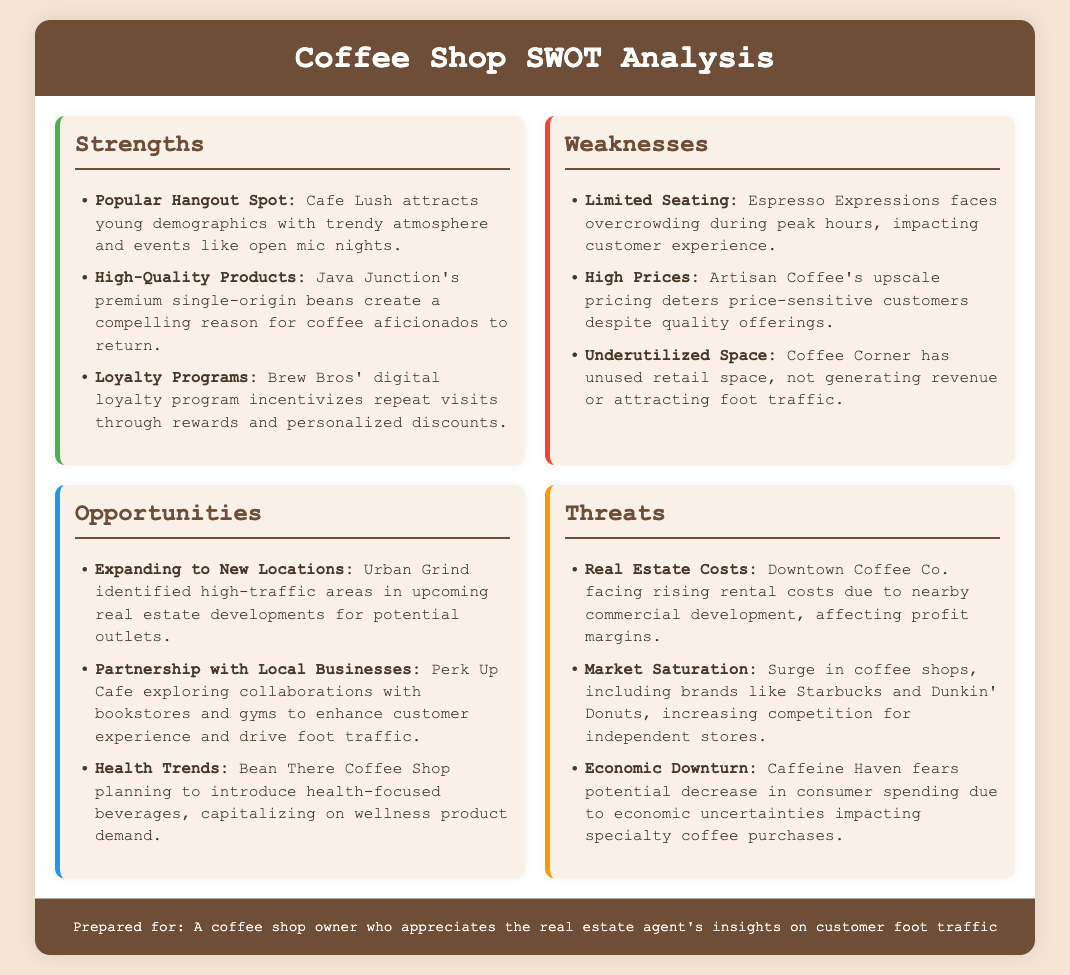What is a popular event at Cafe Lush? The document states that Cafe Lush attracts customers with events like open mic nights.
Answer: open mic nights What is a common weakness for Espresso Expressions? The document notes that Espresso Expressions faces overcrowding during peak hours, which impacts customer experience.
Answer: Limited Seating Which coffee shop has a digital loyalty program? Brew Bros' digital loyalty program is mentioned as a strength in the document, designed to incentivize repeat visits.
Answer: Brew Bros What opportunity is Urban Grind exploring? The document mentions Urban Grind identified high-traffic areas in upcoming real estate developments for potential outlets.
Answer: Expanding to New Locations What is a threat faced by Downtown Coffee Co.? The document notes that Downtown Coffee Co. is facing rising rental costs due to nearby commercial development.
Answer: Real Estate Costs Why might Caffeine Haven experience decreased sales? According to the document, Caffeine Haven fears potential decrease in consumer spending due to economic uncertainties.
Answer: Economic Downturn Which coffee shop is planning to introduce health-focused beverages? The document indicates that Bean There Coffee Shop is planning to introduce health-focused beverages.
Answer: Bean There Coffee Shop What is a weakness of Coffee Corner? The document highlights that Coffee Corner has underutilized space not generating revenue or attracting foot traffic.
Answer: Underutilized Space What are the high competition brands mentioned in the threats? The document lists Starbucks and Dunkin' Donuts as brands increasing competition for independent stores.
Answer: Starbucks and Dunkin' Donuts 